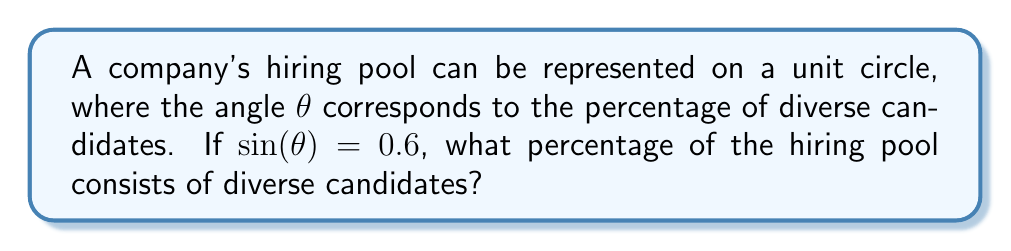Provide a solution to this math problem. To solve this problem, we'll follow these steps:

1) We're given that $\sin(\theta) = 0.6$ on the unit circle.

2) In the unit circle, $\sin(\theta)$ represents the y-coordinate. The angle $\theta$ represents the proportion of the full circle, which corresponds to the percentage of diverse candidates.

3) To find $\theta$, we need to use the inverse sine function (arcsin):

   $$\theta = \arcsin(0.6)$$

4) Using a calculator or trigonometric tables, we find:

   $$\theta \approx 0.6435 \text{ radians}$$

5) To convert this to a percentage, we need to compare it to a full circle (2π radians):

   $$\text{Percentage} = \frac{\theta}{2\pi} \times 100\%$$

6) Substituting our value:

   $$\text{Percentage} = \frac{0.6435}{2\pi} \times 100\% \approx 36.87\%$$

[asy]
unitsize(2cm);
draw(unitcircle);
draw((-1.1,0)--(1.1,0),arrow=Arrow(TeXHead));
draw((0,-1.1)--(0,1.1),arrow=Arrow(TeXHead));
pair A = (cos(0.6435),sin(0.6435));
draw((0,0)--A,arrow=Arrow(TeXHead));
label("$\theta$",(0.2,0.2));
label("$\sin(\theta)=0.6$",(0,0.6),W);
[/asy]
Answer: The hiring pool consists of approximately 36.87% diverse candidates. 